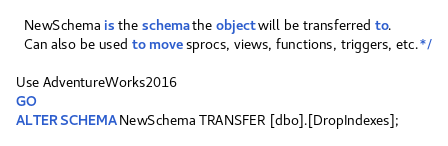Convert code to text. <code><loc_0><loc_0><loc_500><loc_500><_SQL_>  NewSchema is the schema the object will be transferred to.
  Can also be used to move sprocs, views, functions, triggers, etc.*/

Use AdventureWorks2016
GO
ALTER SCHEMA NewSchema TRANSFER [dbo].[DropIndexes];</code> 